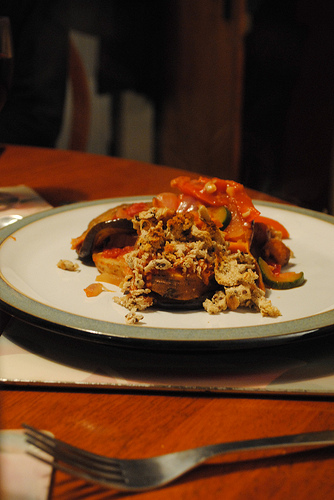<image>
Is the fork on the plate? No. The fork is not positioned on the plate. They may be near each other, but the fork is not supported by or resting on top of the plate. 